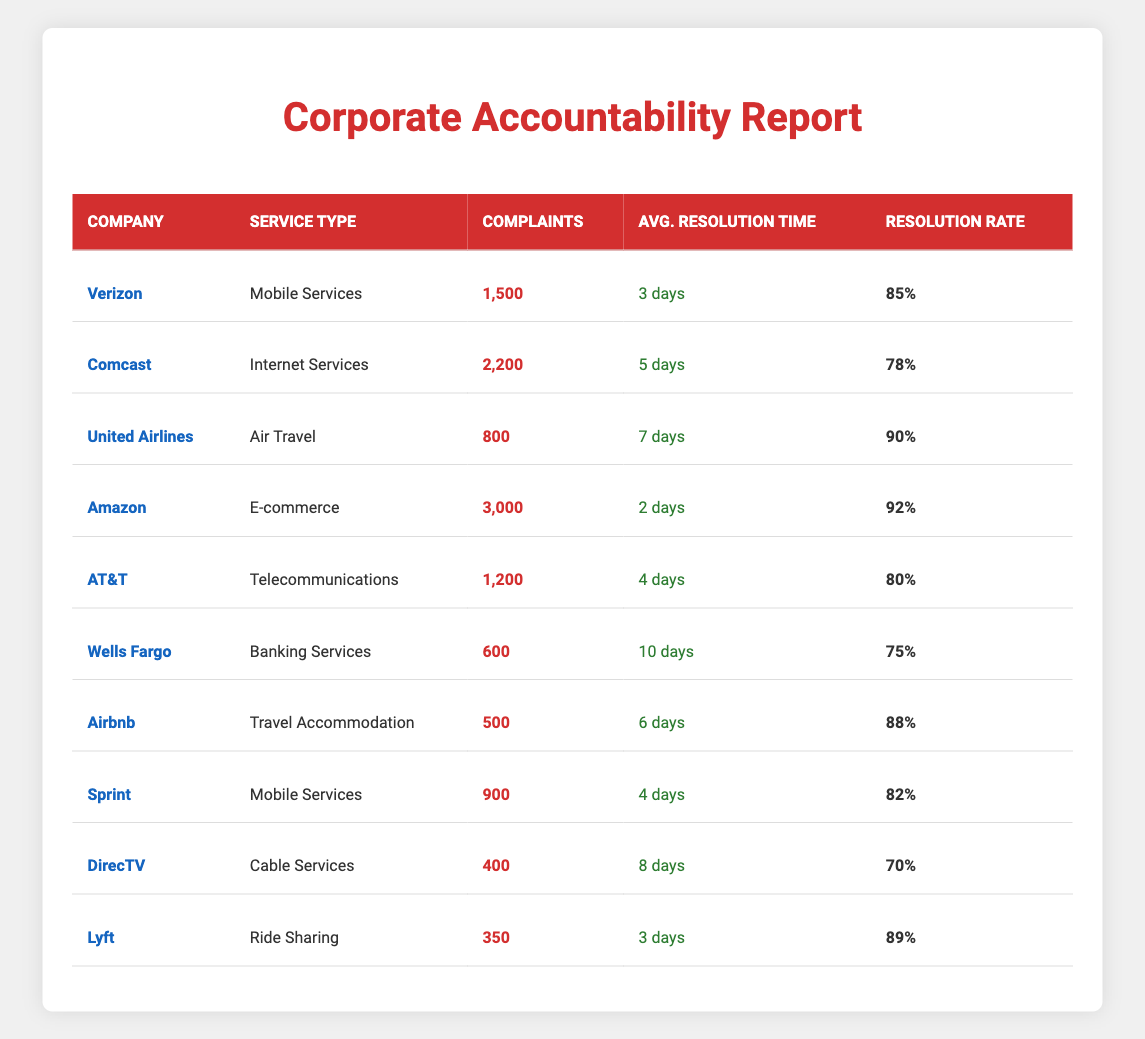What company has the highest resolution rate? By examining the "Resolution Rate" column, I see that Amazon has the highest resolution rate at 92%.
Answer: Amazon How many complaints did Comcast receive? The "Complaints" column indicates that Comcast received 2,200 complaints.
Answer: 2,200 What is the average resolution time for Verizon? The "Avg. Resolution Time" column shows that Verizon has an average resolution time of 3 days.
Answer: 3 days Which company has the longest average resolution time? Upon reviewing the "Avg. Resolution Time" column, Wells Fargo has the longest average resolution time at 10 days.
Answer: Wells Fargo What is the total number of complaints received by Mobile Services companies? The total complaints for Mobile Services are from Verizon (1,500) and Sprint (900), so I add them: 1,500 + 900 = 2,400.
Answer: 2,400 Which company has a resolution rate below 80%? Looking at the "Resolution Rate" column, I see that both Comcast (78%) and DirecTV (70%) have rates below 80%.
Answer: Comcast and DirecTV What is the difference in average resolution time between Amazon and United Airlines? Amazon's average resolution time is 2 days, while United Airlines' is 7 days. The difference is 7 - 2 = 5 days.
Answer: 5 days How many companies listed have a resolution rate above 85%? The companies with a resolution rate above 85% are Amazon (92%), United Airlines (90%), and Verizon (85%), totaling three companies.
Answer: 3 companies Which service type has the fewest complaints? I compare the "Complaints" column and find that Travel Accommodation (Airbnb) has the fewest complaints at 500.
Answer: Travel Accommodation What is the average resolution time across all listed companies? I sum all average resolution times: (3 + 5 + 7 + 2 + 4 + 10 + 6 + 4 + 8 + 3) = 52 days. There are 10 companies, so the average is 52/10 = 5.2 days.
Answer: 5.2 days Is there any company with more than 1000 complaints that resolves them in less than four days? By reviewing both columns, I see that Verizon (1,500 complaints) resolves them in 3 days, which answers yes.
Answer: Yes 